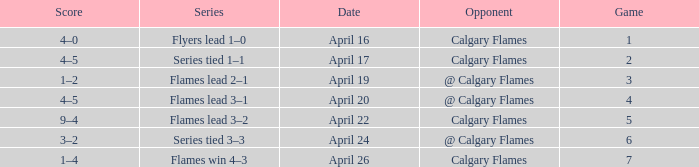Which Date has a Game smaller than 4, and an Opponent of calgary flames, and a Score of 4–5? April 17. 